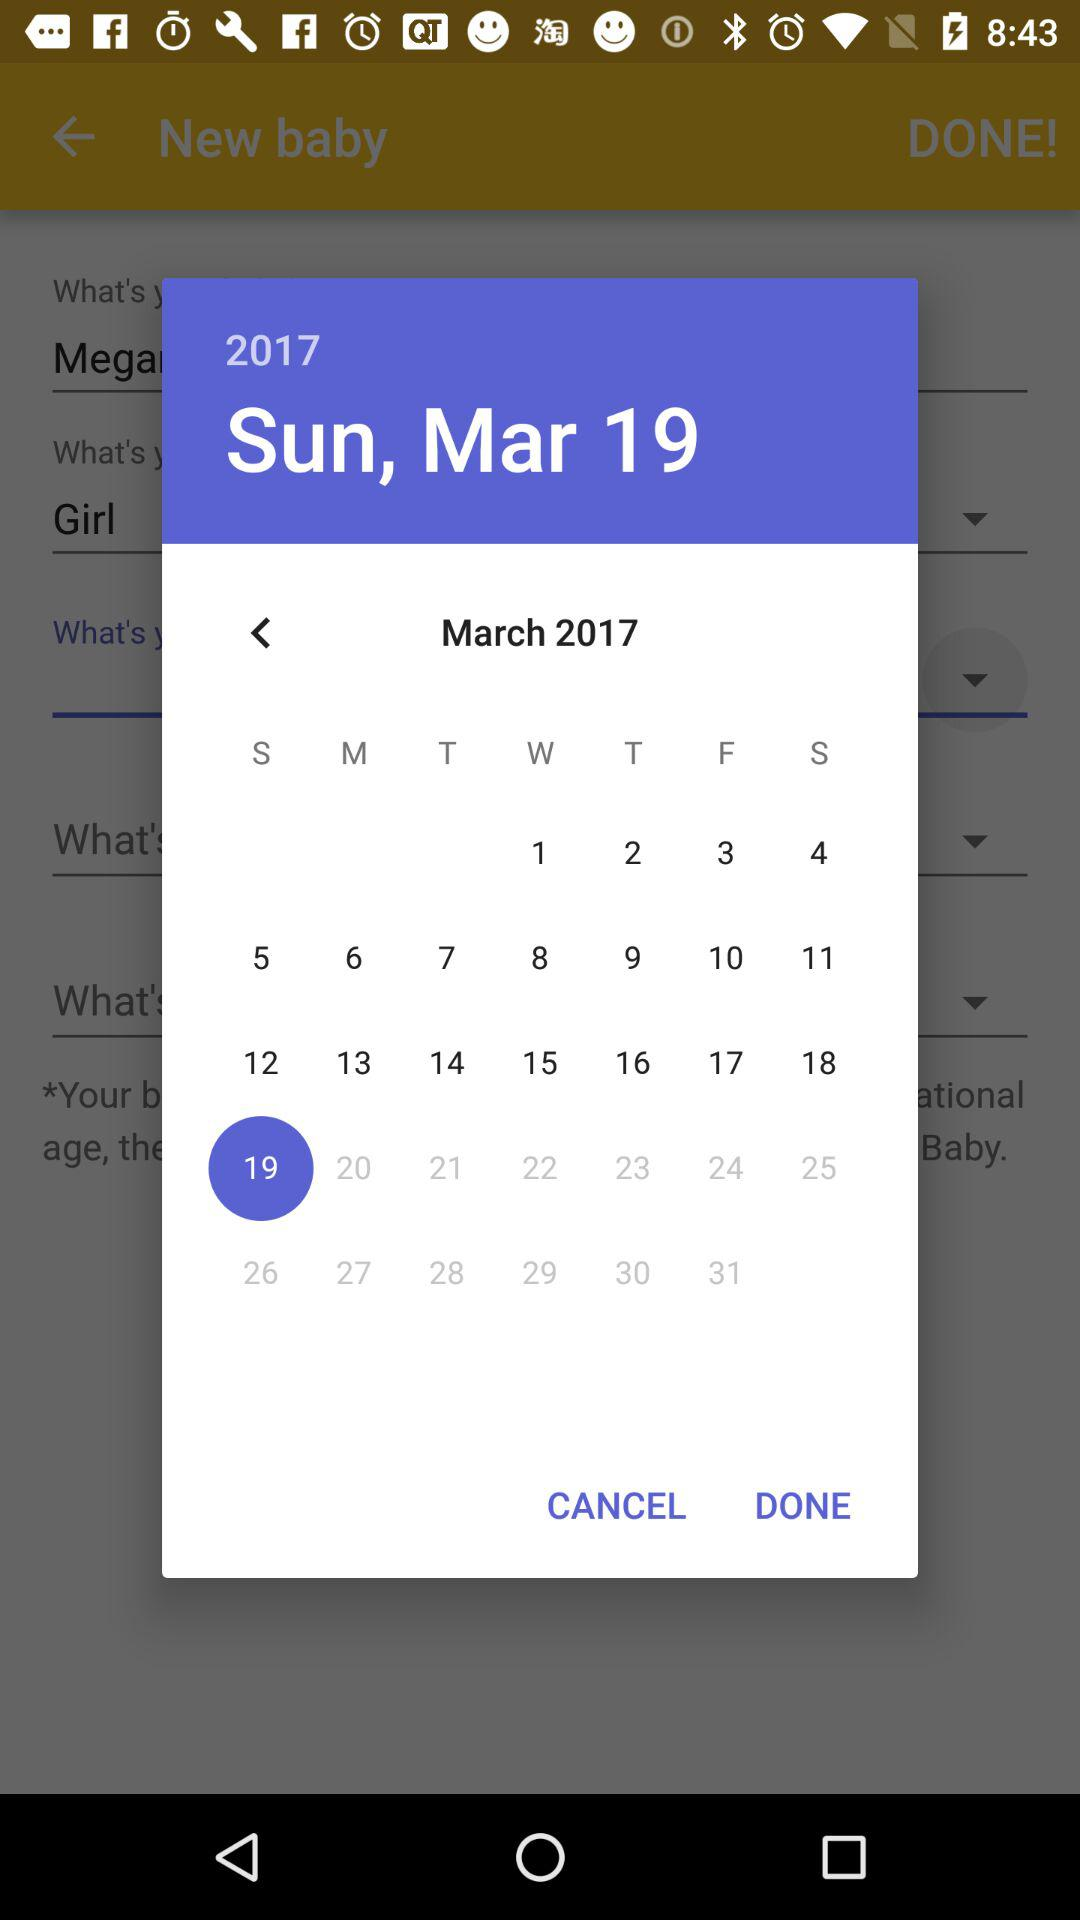What date is selected? The selected date is Sunday, March 19, 2017. 